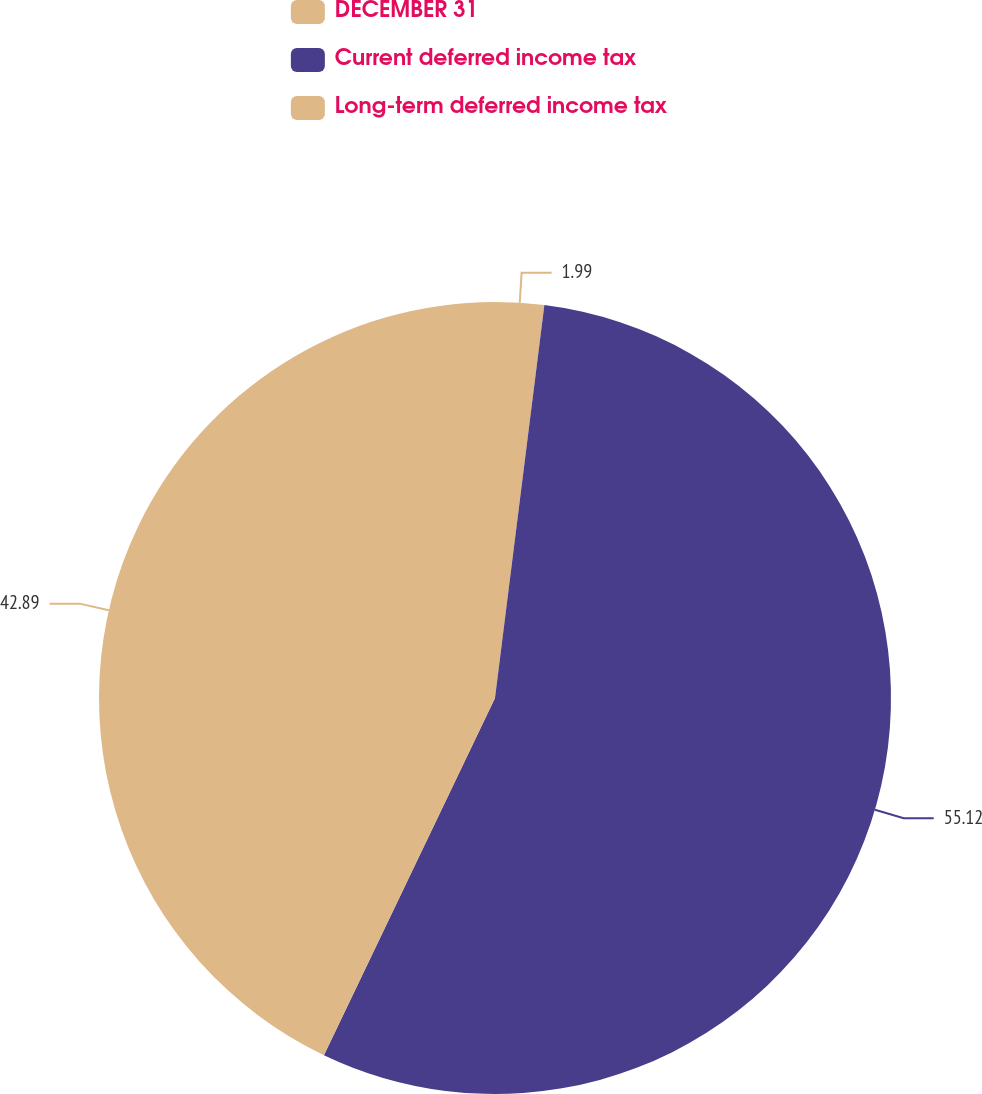<chart> <loc_0><loc_0><loc_500><loc_500><pie_chart><fcel>DECEMBER 31<fcel>Current deferred income tax<fcel>Long-term deferred income tax<nl><fcel>1.99%<fcel>55.12%<fcel>42.89%<nl></chart> 